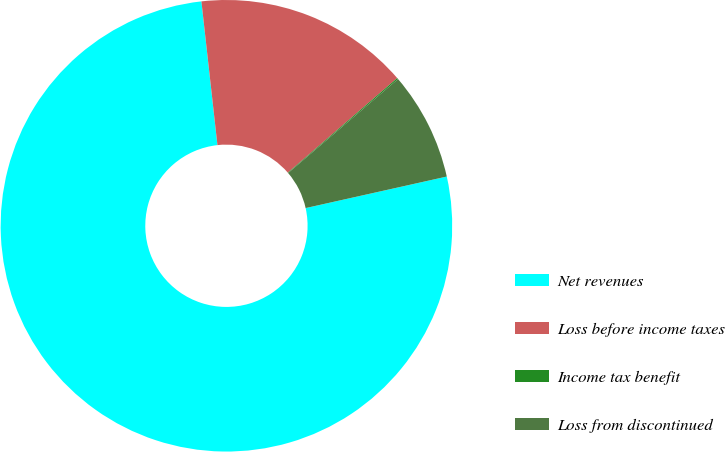<chart> <loc_0><loc_0><loc_500><loc_500><pie_chart><fcel>Net revenues<fcel>Loss before income taxes<fcel>Income tax benefit<fcel>Loss from discontinued<nl><fcel>76.73%<fcel>15.42%<fcel>0.09%<fcel>7.76%<nl></chart> 